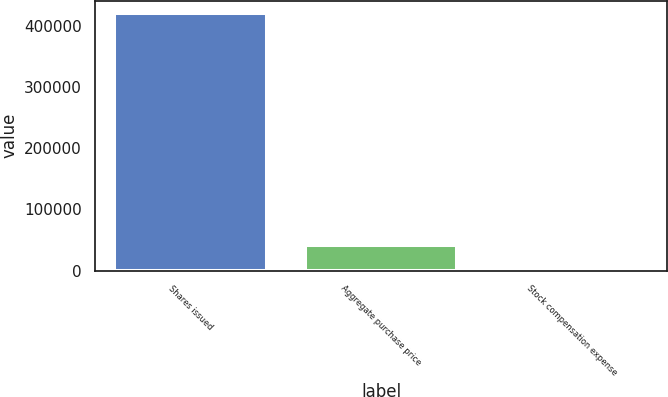Convert chart to OTSL. <chart><loc_0><loc_0><loc_500><loc_500><bar_chart><fcel>Shares issued<fcel>Aggregate purchase price<fcel>Stock compensation expense<nl><fcel>420000<fcel>42001.4<fcel>1.6<nl></chart> 